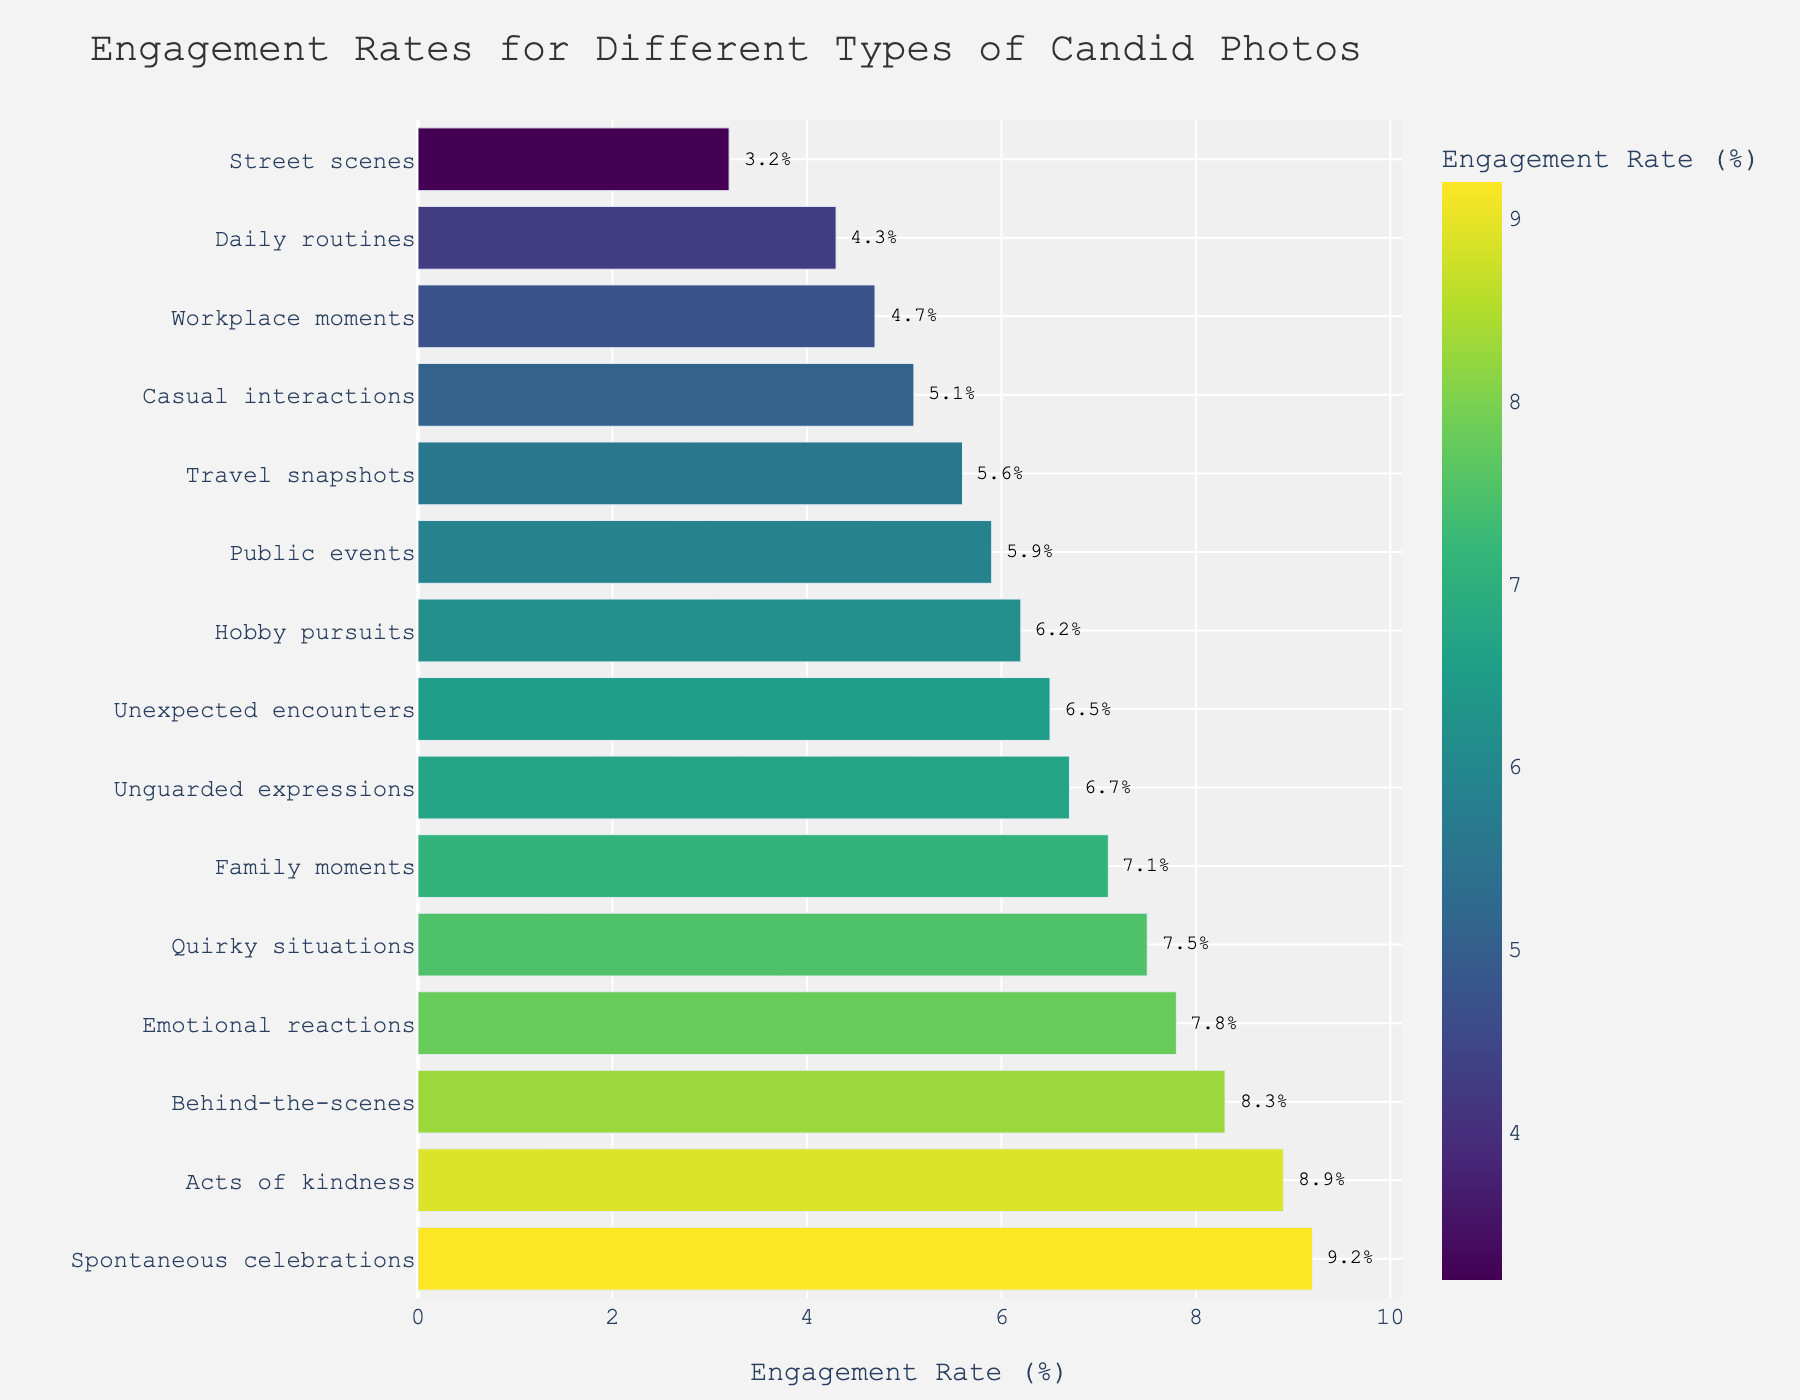What's the photo type with the highest engagement rate? Look for the bar that extends the farthest to the right, which represents the highest engagement rate.
Answer: Spontaneous celebrations Which type of candid photo has a higher engagement rate: 'Workplace moments' or 'Street scenes'? Compare the lengths of the bars for 'Workplace moments' and 'Street scenes'. 'Workplace moments' extends farther to the right.
Answer: Workplace moments What is the difference in engagement rate between 'Emotional reactions' and 'Family moments'? Subtract the engagement rate of 'Family moments' (7.1%) from 'Emotional reactions' (7.8%).
Answer: 0.7% How many types of candid photos have an engagement rate higher than 6%? Count the number of bars that extend beyond the 6% mark.
Answer: 10 What's the average engagement rate for 'Travel snapshots' and 'Daily routines'? Add the engagement rates of 'Travel snapshots' (5.6%) and 'Daily routines' (4.3%), then divide by 2.
Answer: 4.95% Which type of candid photo has more than twice the engagement rate of 'Street scenes'? The engagement rate of 'Street scenes' is 3.2%, so look for bars longer than 6.4%. 'Emotional reactions', 'Unexpected encounters', 'Behind-the-scenes', 'Spontaneous celebrations', 'Family moments', 'Acts of kindness', and 'Quirky situations' qualify.
Answer: Emotional reactions, Unexpected encounters, Behind-the-scenes, Spontaneous celebrations, Family moments, Acts of kindness, Quirky situations What is the median engagement rate of all the types of candid photos? List all engagement rates in ascending order and find the middle value. The sorted list is: 3.2, 4.3, 4.7, 5.1, 5.6, 5.9, 6.2, 6.5, 6.7, 7.1, 7.5, 7.8, 8.3, 8.9, 9.2. The median is the 8th value in this list.
Answer: 6.5% How does the engagement rate for 'Acts of kindness' compare to 'Quirky situations'? Compare the lengths of the bars for 'Acts of kindness' (8.9%) and 'Quirky situations' (7.5%).
Answer: Acts of kindness is higher Which types of candid photos have engagement rates between 5% and 7%? Identify bars whose lengths fall between the 5% and 7% markings. These are 'Public events', 'Casual interactions', 'Travel snapshots', 'Unguarded expressions', 'Family moments', 'Hobby pursuits'.
Answer: Public events, Casual interactions, Travel snapshots, Unguarded expressions, Family moments, Hobby pursuits 